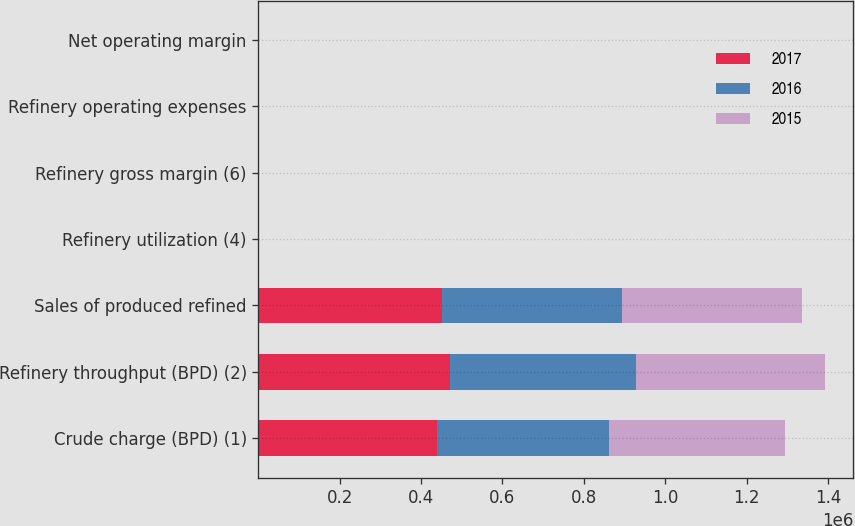<chart> <loc_0><loc_0><loc_500><loc_500><stacked_bar_chart><ecel><fcel>Crude charge (BPD) (1)<fcel>Refinery throughput (BPD) (2)<fcel>Sales of produced refined<fcel>Refinery utilization (4)<fcel>Refinery gross margin (6)<fcel>Refinery operating expenses<fcel>Net operating margin<nl><fcel>2017<fcel>438800<fcel>472010<fcel>452270<fcel>96<fcel>11.56<fcel>5.84<fcel>5.46<nl><fcel>2016<fcel>423910<fcel>457480<fcel>440640<fcel>92.8<fcel>8.16<fcel>5.43<fcel>2.52<nl><fcel>2015<fcel>432560<fcel>463580<fcel>442650<fcel>97.6<fcel>15.88<fcel>5.56<fcel>10.06<nl></chart> 